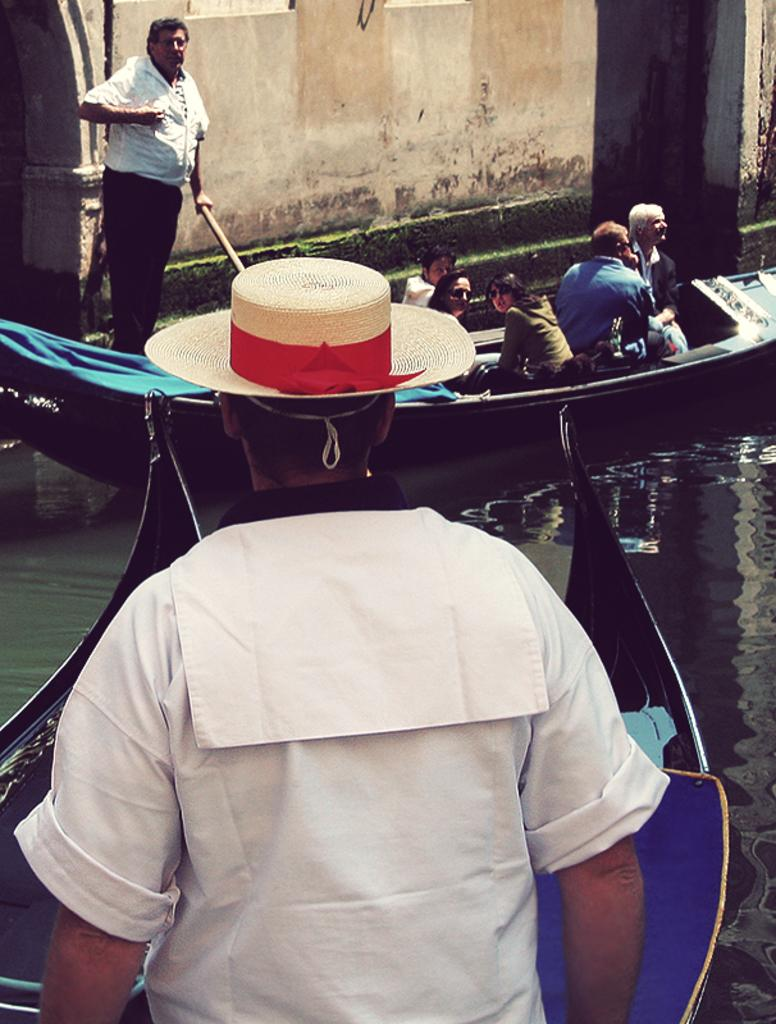What is in the water in the image? There are boats in the water. What are the boats being used for? People are sitting in the boats, suggesting they are being used for transportation or leisure. Can you describe the person standing in front of the boats? The person standing in front of the boats is wearing a white dress. What type of fruit is being washed in the water near the boats? There is no fruit visible in the image, and no indication that any fruit is being washed in the water. 